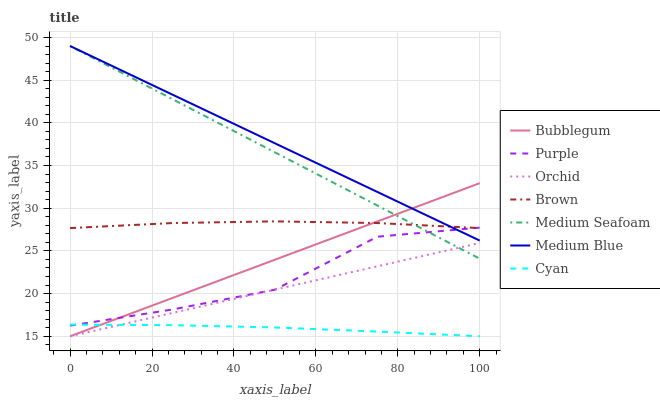Does Cyan have the minimum area under the curve?
Answer yes or no. Yes. Does Medium Blue have the maximum area under the curve?
Answer yes or no. Yes. Does Purple have the minimum area under the curve?
Answer yes or no. No. Does Purple have the maximum area under the curve?
Answer yes or no. No. Is Bubblegum the smoothest?
Answer yes or no. Yes. Is Purple the roughest?
Answer yes or no. Yes. Is Medium Blue the smoothest?
Answer yes or no. No. Is Medium Blue the roughest?
Answer yes or no. No. Does Bubblegum have the lowest value?
Answer yes or no. Yes. Does Purple have the lowest value?
Answer yes or no. No. Does Medium Seafoam have the highest value?
Answer yes or no. Yes. Does Purple have the highest value?
Answer yes or no. No. Is Cyan less than Brown?
Answer yes or no. Yes. Is Medium Blue greater than Cyan?
Answer yes or no. Yes. Does Purple intersect Bubblegum?
Answer yes or no. Yes. Is Purple less than Bubblegum?
Answer yes or no. No. Is Purple greater than Bubblegum?
Answer yes or no. No. Does Cyan intersect Brown?
Answer yes or no. No. 